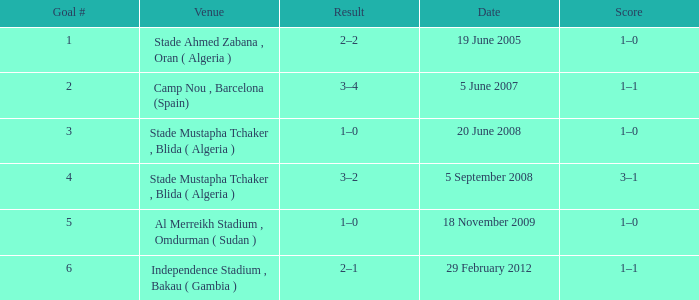What was the venue where goal #2 occured? Camp Nou , Barcelona (Spain). 